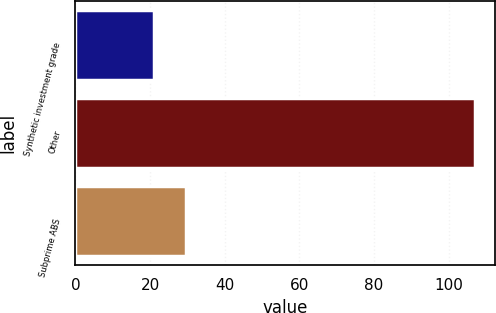<chart> <loc_0><loc_0><loc_500><loc_500><bar_chart><fcel>Synthetic investment grade<fcel>Other<fcel>Subprime ABS<nl><fcel>21<fcel>107<fcel>29.6<nl></chart> 